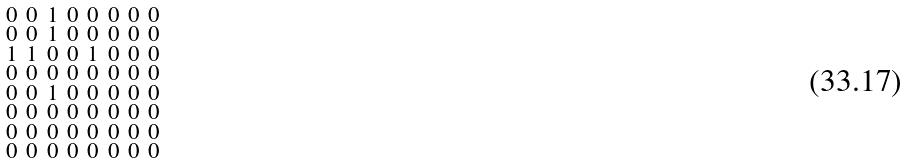Convert formula to latex. <formula><loc_0><loc_0><loc_500><loc_500>\begin{smallmatrix} 0 & 0 & 1 & 0 & 0 & 0 & 0 & 0 \\ 0 & 0 & 1 & 0 & 0 & 0 & 0 & 0 \\ 1 & 1 & 0 & 0 & 1 & 0 & 0 & 0 \\ 0 & 0 & 0 & 0 & 0 & 0 & 0 & 0 \\ 0 & 0 & 1 & 0 & 0 & 0 & 0 & 0 \\ 0 & 0 & 0 & 0 & 0 & 0 & 0 & 0 \\ 0 & 0 & 0 & 0 & 0 & 0 & 0 & 0 \\ 0 & 0 & 0 & 0 & 0 & 0 & 0 & 0 \end{smallmatrix}</formula> 